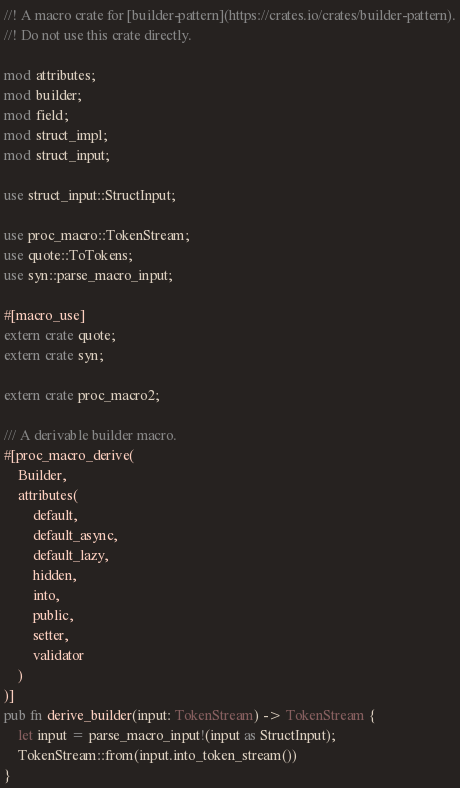Convert code to text. <code><loc_0><loc_0><loc_500><loc_500><_Rust_>//! A macro crate for [builder-pattern](https://crates.io/crates/builder-pattern).
//! Do not use this crate directly.

mod attributes;
mod builder;
mod field;
mod struct_impl;
mod struct_input;

use struct_input::StructInput;

use proc_macro::TokenStream;
use quote::ToTokens;
use syn::parse_macro_input;

#[macro_use]
extern crate quote;
extern crate syn;

extern crate proc_macro2;

/// A derivable builder macro.
#[proc_macro_derive(
    Builder,
    attributes(
        default,
        default_async,
        default_lazy,
        hidden,
        into,
        public,
        setter,
        validator
    )
)]
pub fn derive_builder(input: TokenStream) -> TokenStream {
    let input = parse_macro_input!(input as StructInput);
    TokenStream::from(input.into_token_stream())
}
</code> 